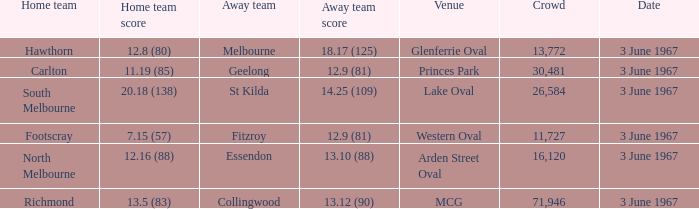Who was South Melbourne's away opponents? St Kilda. 